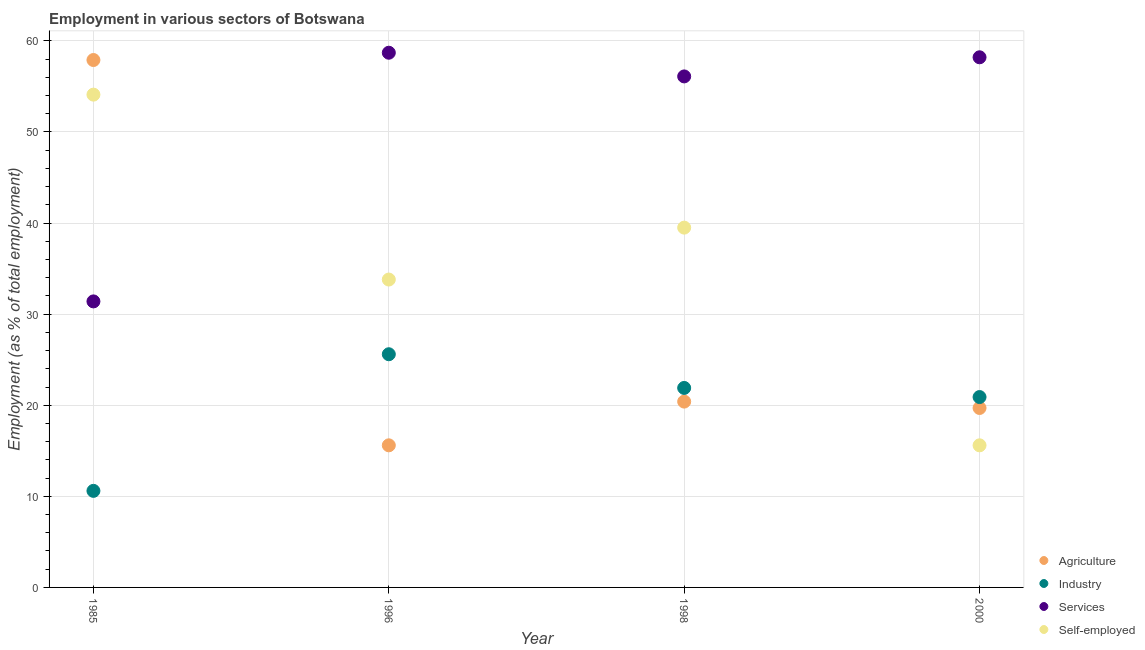Is the number of dotlines equal to the number of legend labels?
Your answer should be compact. Yes. What is the percentage of workers in industry in 2000?
Your answer should be compact. 20.9. Across all years, what is the maximum percentage of workers in services?
Provide a short and direct response. 58.7. Across all years, what is the minimum percentage of workers in agriculture?
Provide a short and direct response. 15.6. In which year was the percentage of workers in services minimum?
Your response must be concise. 1985. What is the total percentage of workers in agriculture in the graph?
Give a very brief answer. 113.6. What is the difference between the percentage of workers in services in 1985 and that in 2000?
Your response must be concise. -26.8. What is the difference between the percentage of workers in agriculture in 1985 and the percentage of self employed workers in 1998?
Keep it short and to the point. 18.4. What is the average percentage of workers in industry per year?
Make the answer very short. 19.75. In the year 1998, what is the difference between the percentage of workers in services and percentage of workers in agriculture?
Provide a short and direct response. 35.7. In how many years, is the percentage of workers in industry greater than 54 %?
Your answer should be very brief. 0. What is the ratio of the percentage of self employed workers in 1985 to that in 1998?
Give a very brief answer. 1.37. Is the difference between the percentage of workers in services in 1998 and 2000 greater than the difference between the percentage of workers in industry in 1998 and 2000?
Provide a succinct answer. No. What is the difference between the highest and the second highest percentage of workers in industry?
Your response must be concise. 3.7. What is the difference between the highest and the lowest percentage of workers in industry?
Your answer should be compact. 15. In how many years, is the percentage of self employed workers greater than the average percentage of self employed workers taken over all years?
Provide a succinct answer. 2. Is it the case that in every year, the sum of the percentage of workers in agriculture and percentage of workers in industry is greater than the percentage of workers in services?
Offer a very short reply. No. Is the percentage of workers in agriculture strictly greater than the percentage of workers in industry over the years?
Make the answer very short. No. Is the percentage of workers in agriculture strictly less than the percentage of workers in services over the years?
Provide a short and direct response. No. How many years are there in the graph?
Your response must be concise. 4. Does the graph contain any zero values?
Make the answer very short. No. Does the graph contain grids?
Your response must be concise. Yes. Where does the legend appear in the graph?
Keep it short and to the point. Bottom right. What is the title of the graph?
Provide a succinct answer. Employment in various sectors of Botswana. Does "Source data assessment" appear as one of the legend labels in the graph?
Provide a short and direct response. No. What is the label or title of the Y-axis?
Provide a short and direct response. Employment (as % of total employment). What is the Employment (as % of total employment) in Agriculture in 1985?
Provide a succinct answer. 57.9. What is the Employment (as % of total employment) in Industry in 1985?
Provide a short and direct response. 10.6. What is the Employment (as % of total employment) of Services in 1985?
Provide a short and direct response. 31.4. What is the Employment (as % of total employment) of Self-employed in 1985?
Offer a very short reply. 54.1. What is the Employment (as % of total employment) in Agriculture in 1996?
Ensure brevity in your answer.  15.6. What is the Employment (as % of total employment) in Industry in 1996?
Your answer should be compact. 25.6. What is the Employment (as % of total employment) in Services in 1996?
Your answer should be very brief. 58.7. What is the Employment (as % of total employment) of Self-employed in 1996?
Offer a very short reply. 33.8. What is the Employment (as % of total employment) in Agriculture in 1998?
Provide a succinct answer. 20.4. What is the Employment (as % of total employment) of Industry in 1998?
Your answer should be compact. 21.9. What is the Employment (as % of total employment) of Services in 1998?
Provide a succinct answer. 56.1. What is the Employment (as % of total employment) in Self-employed in 1998?
Give a very brief answer. 39.5. What is the Employment (as % of total employment) of Agriculture in 2000?
Your answer should be very brief. 19.7. What is the Employment (as % of total employment) in Industry in 2000?
Your response must be concise. 20.9. What is the Employment (as % of total employment) in Services in 2000?
Give a very brief answer. 58.2. What is the Employment (as % of total employment) in Self-employed in 2000?
Your response must be concise. 15.6. Across all years, what is the maximum Employment (as % of total employment) of Agriculture?
Your response must be concise. 57.9. Across all years, what is the maximum Employment (as % of total employment) in Industry?
Provide a succinct answer. 25.6. Across all years, what is the maximum Employment (as % of total employment) in Services?
Make the answer very short. 58.7. Across all years, what is the maximum Employment (as % of total employment) of Self-employed?
Provide a short and direct response. 54.1. Across all years, what is the minimum Employment (as % of total employment) in Agriculture?
Provide a short and direct response. 15.6. Across all years, what is the minimum Employment (as % of total employment) of Industry?
Offer a very short reply. 10.6. Across all years, what is the minimum Employment (as % of total employment) in Services?
Provide a short and direct response. 31.4. Across all years, what is the minimum Employment (as % of total employment) of Self-employed?
Make the answer very short. 15.6. What is the total Employment (as % of total employment) of Agriculture in the graph?
Your answer should be very brief. 113.6. What is the total Employment (as % of total employment) of Industry in the graph?
Your answer should be very brief. 79. What is the total Employment (as % of total employment) in Services in the graph?
Your answer should be compact. 204.4. What is the total Employment (as % of total employment) in Self-employed in the graph?
Your answer should be very brief. 143. What is the difference between the Employment (as % of total employment) in Agriculture in 1985 and that in 1996?
Make the answer very short. 42.3. What is the difference between the Employment (as % of total employment) of Industry in 1985 and that in 1996?
Ensure brevity in your answer.  -15. What is the difference between the Employment (as % of total employment) in Services in 1985 and that in 1996?
Ensure brevity in your answer.  -27.3. What is the difference between the Employment (as % of total employment) of Self-employed in 1985 and that in 1996?
Your answer should be very brief. 20.3. What is the difference between the Employment (as % of total employment) in Agriculture in 1985 and that in 1998?
Provide a short and direct response. 37.5. What is the difference between the Employment (as % of total employment) of Industry in 1985 and that in 1998?
Your answer should be compact. -11.3. What is the difference between the Employment (as % of total employment) in Services in 1985 and that in 1998?
Offer a terse response. -24.7. What is the difference between the Employment (as % of total employment) in Self-employed in 1985 and that in 1998?
Offer a terse response. 14.6. What is the difference between the Employment (as % of total employment) in Agriculture in 1985 and that in 2000?
Give a very brief answer. 38.2. What is the difference between the Employment (as % of total employment) of Industry in 1985 and that in 2000?
Your answer should be compact. -10.3. What is the difference between the Employment (as % of total employment) of Services in 1985 and that in 2000?
Offer a terse response. -26.8. What is the difference between the Employment (as % of total employment) of Self-employed in 1985 and that in 2000?
Ensure brevity in your answer.  38.5. What is the difference between the Employment (as % of total employment) in Services in 1996 and that in 1998?
Offer a terse response. 2.6. What is the difference between the Employment (as % of total employment) of Self-employed in 1996 and that in 1998?
Offer a terse response. -5.7. What is the difference between the Employment (as % of total employment) of Agriculture in 1996 and that in 2000?
Provide a succinct answer. -4.1. What is the difference between the Employment (as % of total employment) of Self-employed in 1996 and that in 2000?
Keep it short and to the point. 18.2. What is the difference between the Employment (as % of total employment) in Agriculture in 1998 and that in 2000?
Offer a very short reply. 0.7. What is the difference between the Employment (as % of total employment) of Industry in 1998 and that in 2000?
Your answer should be compact. 1. What is the difference between the Employment (as % of total employment) in Services in 1998 and that in 2000?
Your answer should be very brief. -2.1. What is the difference between the Employment (as % of total employment) of Self-employed in 1998 and that in 2000?
Your response must be concise. 23.9. What is the difference between the Employment (as % of total employment) of Agriculture in 1985 and the Employment (as % of total employment) of Industry in 1996?
Give a very brief answer. 32.3. What is the difference between the Employment (as % of total employment) in Agriculture in 1985 and the Employment (as % of total employment) in Services in 1996?
Ensure brevity in your answer.  -0.8. What is the difference between the Employment (as % of total employment) in Agriculture in 1985 and the Employment (as % of total employment) in Self-employed in 1996?
Make the answer very short. 24.1. What is the difference between the Employment (as % of total employment) in Industry in 1985 and the Employment (as % of total employment) in Services in 1996?
Your answer should be compact. -48.1. What is the difference between the Employment (as % of total employment) of Industry in 1985 and the Employment (as % of total employment) of Self-employed in 1996?
Make the answer very short. -23.2. What is the difference between the Employment (as % of total employment) of Services in 1985 and the Employment (as % of total employment) of Self-employed in 1996?
Offer a very short reply. -2.4. What is the difference between the Employment (as % of total employment) in Industry in 1985 and the Employment (as % of total employment) in Services in 1998?
Your answer should be very brief. -45.5. What is the difference between the Employment (as % of total employment) of Industry in 1985 and the Employment (as % of total employment) of Self-employed in 1998?
Give a very brief answer. -28.9. What is the difference between the Employment (as % of total employment) in Services in 1985 and the Employment (as % of total employment) in Self-employed in 1998?
Make the answer very short. -8.1. What is the difference between the Employment (as % of total employment) in Agriculture in 1985 and the Employment (as % of total employment) in Self-employed in 2000?
Provide a succinct answer. 42.3. What is the difference between the Employment (as % of total employment) in Industry in 1985 and the Employment (as % of total employment) in Services in 2000?
Your answer should be compact. -47.6. What is the difference between the Employment (as % of total employment) of Services in 1985 and the Employment (as % of total employment) of Self-employed in 2000?
Your answer should be very brief. 15.8. What is the difference between the Employment (as % of total employment) in Agriculture in 1996 and the Employment (as % of total employment) in Services in 1998?
Your answer should be compact. -40.5. What is the difference between the Employment (as % of total employment) in Agriculture in 1996 and the Employment (as % of total employment) in Self-employed in 1998?
Offer a terse response. -23.9. What is the difference between the Employment (as % of total employment) in Industry in 1996 and the Employment (as % of total employment) in Services in 1998?
Your answer should be very brief. -30.5. What is the difference between the Employment (as % of total employment) in Agriculture in 1996 and the Employment (as % of total employment) in Services in 2000?
Offer a very short reply. -42.6. What is the difference between the Employment (as % of total employment) in Industry in 1996 and the Employment (as % of total employment) in Services in 2000?
Your response must be concise. -32.6. What is the difference between the Employment (as % of total employment) in Industry in 1996 and the Employment (as % of total employment) in Self-employed in 2000?
Your answer should be very brief. 10. What is the difference between the Employment (as % of total employment) in Services in 1996 and the Employment (as % of total employment) in Self-employed in 2000?
Give a very brief answer. 43.1. What is the difference between the Employment (as % of total employment) in Agriculture in 1998 and the Employment (as % of total employment) in Industry in 2000?
Provide a short and direct response. -0.5. What is the difference between the Employment (as % of total employment) of Agriculture in 1998 and the Employment (as % of total employment) of Services in 2000?
Keep it short and to the point. -37.8. What is the difference between the Employment (as % of total employment) in Agriculture in 1998 and the Employment (as % of total employment) in Self-employed in 2000?
Keep it short and to the point. 4.8. What is the difference between the Employment (as % of total employment) of Industry in 1998 and the Employment (as % of total employment) of Services in 2000?
Your answer should be compact. -36.3. What is the difference between the Employment (as % of total employment) of Industry in 1998 and the Employment (as % of total employment) of Self-employed in 2000?
Give a very brief answer. 6.3. What is the difference between the Employment (as % of total employment) of Services in 1998 and the Employment (as % of total employment) of Self-employed in 2000?
Provide a short and direct response. 40.5. What is the average Employment (as % of total employment) of Agriculture per year?
Give a very brief answer. 28.4. What is the average Employment (as % of total employment) of Industry per year?
Your response must be concise. 19.75. What is the average Employment (as % of total employment) in Services per year?
Provide a short and direct response. 51.1. What is the average Employment (as % of total employment) of Self-employed per year?
Offer a very short reply. 35.75. In the year 1985, what is the difference between the Employment (as % of total employment) in Agriculture and Employment (as % of total employment) in Industry?
Your answer should be compact. 47.3. In the year 1985, what is the difference between the Employment (as % of total employment) in Industry and Employment (as % of total employment) in Services?
Your response must be concise. -20.8. In the year 1985, what is the difference between the Employment (as % of total employment) of Industry and Employment (as % of total employment) of Self-employed?
Provide a succinct answer. -43.5. In the year 1985, what is the difference between the Employment (as % of total employment) in Services and Employment (as % of total employment) in Self-employed?
Provide a short and direct response. -22.7. In the year 1996, what is the difference between the Employment (as % of total employment) in Agriculture and Employment (as % of total employment) in Industry?
Ensure brevity in your answer.  -10. In the year 1996, what is the difference between the Employment (as % of total employment) of Agriculture and Employment (as % of total employment) of Services?
Provide a short and direct response. -43.1. In the year 1996, what is the difference between the Employment (as % of total employment) of Agriculture and Employment (as % of total employment) of Self-employed?
Give a very brief answer. -18.2. In the year 1996, what is the difference between the Employment (as % of total employment) of Industry and Employment (as % of total employment) of Services?
Keep it short and to the point. -33.1. In the year 1996, what is the difference between the Employment (as % of total employment) in Industry and Employment (as % of total employment) in Self-employed?
Your response must be concise. -8.2. In the year 1996, what is the difference between the Employment (as % of total employment) in Services and Employment (as % of total employment) in Self-employed?
Your response must be concise. 24.9. In the year 1998, what is the difference between the Employment (as % of total employment) in Agriculture and Employment (as % of total employment) in Services?
Offer a very short reply. -35.7. In the year 1998, what is the difference between the Employment (as % of total employment) of Agriculture and Employment (as % of total employment) of Self-employed?
Keep it short and to the point. -19.1. In the year 1998, what is the difference between the Employment (as % of total employment) of Industry and Employment (as % of total employment) of Services?
Give a very brief answer. -34.2. In the year 1998, what is the difference between the Employment (as % of total employment) in Industry and Employment (as % of total employment) in Self-employed?
Your answer should be compact. -17.6. In the year 1998, what is the difference between the Employment (as % of total employment) of Services and Employment (as % of total employment) of Self-employed?
Offer a very short reply. 16.6. In the year 2000, what is the difference between the Employment (as % of total employment) in Agriculture and Employment (as % of total employment) in Services?
Offer a terse response. -38.5. In the year 2000, what is the difference between the Employment (as % of total employment) of Industry and Employment (as % of total employment) of Services?
Your answer should be very brief. -37.3. In the year 2000, what is the difference between the Employment (as % of total employment) in Industry and Employment (as % of total employment) in Self-employed?
Provide a short and direct response. 5.3. In the year 2000, what is the difference between the Employment (as % of total employment) in Services and Employment (as % of total employment) in Self-employed?
Keep it short and to the point. 42.6. What is the ratio of the Employment (as % of total employment) of Agriculture in 1985 to that in 1996?
Your answer should be compact. 3.71. What is the ratio of the Employment (as % of total employment) in Industry in 1985 to that in 1996?
Your answer should be compact. 0.41. What is the ratio of the Employment (as % of total employment) in Services in 1985 to that in 1996?
Make the answer very short. 0.53. What is the ratio of the Employment (as % of total employment) of Self-employed in 1985 to that in 1996?
Ensure brevity in your answer.  1.6. What is the ratio of the Employment (as % of total employment) in Agriculture in 1985 to that in 1998?
Your response must be concise. 2.84. What is the ratio of the Employment (as % of total employment) in Industry in 1985 to that in 1998?
Ensure brevity in your answer.  0.48. What is the ratio of the Employment (as % of total employment) of Services in 1985 to that in 1998?
Make the answer very short. 0.56. What is the ratio of the Employment (as % of total employment) in Self-employed in 1985 to that in 1998?
Offer a terse response. 1.37. What is the ratio of the Employment (as % of total employment) of Agriculture in 1985 to that in 2000?
Offer a terse response. 2.94. What is the ratio of the Employment (as % of total employment) in Industry in 1985 to that in 2000?
Offer a terse response. 0.51. What is the ratio of the Employment (as % of total employment) of Services in 1985 to that in 2000?
Your response must be concise. 0.54. What is the ratio of the Employment (as % of total employment) of Self-employed in 1985 to that in 2000?
Give a very brief answer. 3.47. What is the ratio of the Employment (as % of total employment) of Agriculture in 1996 to that in 1998?
Offer a very short reply. 0.76. What is the ratio of the Employment (as % of total employment) of Industry in 1996 to that in 1998?
Offer a very short reply. 1.17. What is the ratio of the Employment (as % of total employment) in Services in 1996 to that in 1998?
Keep it short and to the point. 1.05. What is the ratio of the Employment (as % of total employment) in Self-employed in 1996 to that in 1998?
Your answer should be compact. 0.86. What is the ratio of the Employment (as % of total employment) in Agriculture in 1996 to that in 2000?
Offer a very short reply. 0.79. What is the ratio of the Employment (as % of total employment) of Industry in 1996 to that in 2000?
Keep it short and to the point. 1.22. What is the ratio of the Employment (as % of total employment) in Services in 1996 to that in 2000?
Your response must be concise. 1.01. What is the ratio of the Employment (as % of total employment) in Self-employed in 1996 to that in 2000?
Keep it short and to the point. 2.17. What is the ratio of the Employment (as % of total employment) in Agriculture in 1998 to that in 2000?
Make the answer very short. 1.04. What is the ratio of the Employment (as % of total employment) in Industry in 1998 to that in 2000?
Offer a very short reply. 1.05. What is the ratio of the Employment (as % of total employment) in Services in 1998 to that in 2000?
Make the answer very short. 0.96. What is the ratio of the Employment (as % of total employment) of Self-employed in 1998 to that in 2000?
Make the answer very short. 2.53. What is the difference between the highest and the second highest Employment (as % of total employment) of Agriculture?
Provide a short and direct response. 37.5. What is the difference between the highest and the second highest Employment (as % of total employment) of Industry?
Your response must be concise. 3.7. What is the difference between the highest and the second highest Employment (as % of total employment) of Self-employed?
Your answer should be compact. 14.6. What is the difference between the highest and the lowest Employment (as % of total employment) of Agriculture?
Make the answer very short. 42.3. What is the difference between the highest and the lowest Employment (as % of total employment) of Services?
Provide a short and direct response. 27.3. What is the difference between the highest and the lowest Employment (as % of total employment) of Self-employed?
Offer a terse response. 38.5. 